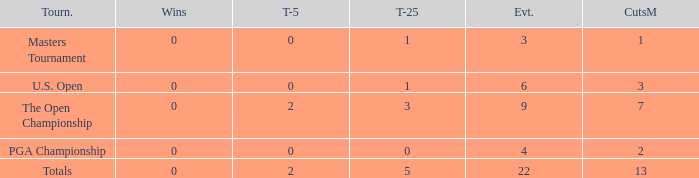What is the total number of wins for events with under 2 top-5s, under 5 top-25s, and more than 4 events played? 1.0. 